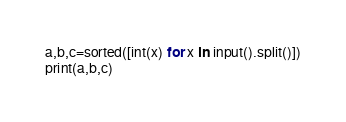<code> <loc_0><loc_0><loc_500><loc_500><_Python_>a,b,c=sorted([int(x) for x in input().split()])
print(a,b,c)
</code> 